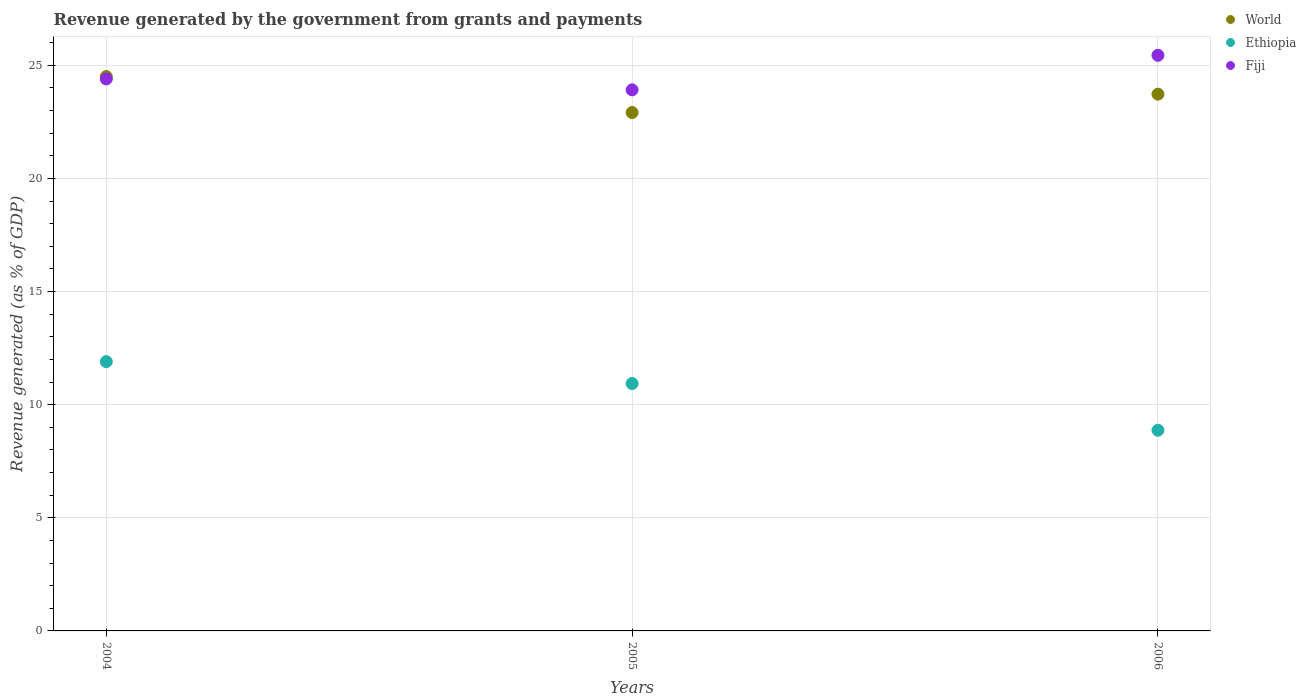How many different coloured dotlines are there?
Provide a succinct answer. 3. Is the number of dotlines equal to the number of legend labels?
Keep it short and to the point. Yes. What is the revenue generated by the government in Ethiopia in 2005?
Provide a short and direct response. 10.94. Across all years, what is the maximum revenue generated by the government in World?
Keep it short and to the point. 24.5. Across all years, what is the minimum revenue generated by the government in Fiji?
Your response must be concise. 23.92. In which year was the revenue generated by the government in World maximum?
Your response must be concise. 2004. What is the total revenue generated by the government in Ethiopia in the graph?
Offer a very short reply. 31.71. What is the difference between the revenue generated by the government in Ethiopia in 2005 and that in 2006?
Offer a very short reply. 2.07. What is the difference between the revenue generated by the government in Fiji in 2006 and the revenue generated by the government in World in 2004?
Keep it short and to the point. 0.94. What is the average revenue generated by the government in World per year?
Give a very brief answer. 23.72. In the year 2004, what is the difference between the revenue generated by the government in Ethiopia and revenue generated by the government in Fiji?
Make the answer very short. -12.5. What is the ratio of the revenue generated by the government in Fiji in 2004 to that in 2006?
Make the answer very short. 0.96. Is the revenue generated by the government in World in 2005 less than that in 2006?
Your answer should be very brief. Yes. What is the difference between the highest and the second highest revenue generated by the government in Ethiopia?
Give a very brief answer. 0.97. What is the difference between the highest and the lowest revenue generated by the government in World?
Your answer should be very brief. 1.59. In how many years, is the revenue generated by the government in World greater than the average revenue generated by the government in World taken over all years?
Keep it short and to the point. 2. Is the sum of the revenue generated by the government in Ethiopia in 2005 and 2006 greater than the maximum revenue generated by the government in World across all years?
Provide a short and direct response. No. Does the revenue generated by the government in Fiji monotonically increase over the years?
Your answer should be very brief. No. Is the revenue generated by the government in Fiji strictly less than the revenue generated by the government in World over the years?
Provide a short and direct response. No. How many years are there in the graph?
Ensure brevity in your answer.  3. What is the difference between two consecutive major ticks on the Y-axis?
Your answer should be compact. 5. Does the graph contain any zero values?
Provide a succinct answer. No. Does the graph contain grids?
Offer a terse response. Yes. How many legend labels are there?
Provide a succinct answer. 3. How are the legend labels stacked?
Give a very brief answer. Vertical. What is the title of the graph?
Your answer should be very brief. Revenue generated by the government from grants and payments. What is the label or title of the X-axis?
Keep it short and to the point. Years. What is the label or title of the Y-axis?
Your answer should be very brief. Revenue generated (as % of GDP). What is the Revenue generated (as % of GDP) in World in 2004?
Your response must be concise. 24.5. What is the Revenue generated (as % of GDP) of Ethiopia in 2004?
Make the answer very short. 11.9. What is the Revenue generated (as % of GDP) of Fiji in 2004?
Ensure brevity in your answer.  24.4. What is the Revenue generated (as % of GDP) of World in 2005?
Offer a terse response. 22.92. What is the Revenue generated (as % of GDP) in Ethiopia in 2005?
Your response must be concise. 10.94. What is the Revenue generated (as % of GDP) of Fiji in 2005?
Ensure brevity in your answer.  23.92. What is the Revenue generated (as % of GDP) in World in 2006?
Keep it short and to the point. 23.73. What is the Revenue generated (as % of GDP) of Ethiopia in 2006?
Offer a very short reply. 8.87. What is the Revenue generated (as % of GDP) in Fiji in 2006?
Give a very brief answer. 25.44. Across all years, what is the maximum Revenue generated (as % of GDP) in World?
Your response must be concise. 24.5. Across all years, what is the maximum Revenue generated (as % of GDP) of Ethiopia?
Your response must be concise. 11.9. Across all years, what is the maximum Revenue generated (as % of GDP) of Fiji?
Your response must be concise. 25.44. Across all years, what is the minimum Revenue generated (as % of GDP) in World?
Your answer should be very brief. 22.92. Across all years, what is the minimum Revenue generated (as % of GDP) in Ethiopia?
Give a very brief answer. 8.87. Across all years, what is the minimum Revenue generated (as % of GDP) in Fiji?
Give a very brief answer. 23.92. What is the total Revenue generated (as % of GDP) of World in the graph?
Your answer should be very brief. 71.15. What is the total Revenue generated (as % of GDP) in Ethiopia in the graph?
Ensure brevity in your answer.  31.71. What is the total Revenue generated (as % of GDP) in Fiji in the graph?
Provide a succinct answer. 73.76. What is the difference between the Revenue generated (as % of GDP) in World in 2004 and that in 2005?
Offer a terse response. 1.59. What is the difference between the Revenue generated (as % of GDP) in Ethiopia in 2004 and that in 2005?
Your response must be concise. 0.97. What is the difference between the Revenue generated (as % of GDP) in Fiji in 2004 and that in 2005?
Give a very brief answer. 0.48. What is the difference between the Revenue generated (as % of GDP) of World in 2004 and that in 2006?
Make the answer very short. 0.78. What is the difference between the Revenue generated (as % of GDP) in Ethiopia in 2004 and that in 2006?
Your answer should be compact. 3.03. What is the difference between the Revenue generated (as % of GDP) of Fiji in 2004 and that in 2006?
Offer a very short reply. -1.04. What is the difference between the Revenue generated (as % of GDP) of World in 2005 and that in 2006?
Keep it short and to the point. -0.81. What is the difference between the Revenue generated (as % of GDP) in Ethiopia in 2005 and that in 2006?
Your answer should be very brief. 2.06. What is the difference between the Revenue generated (as % of GDP) of Fiji in 2005 and that in 2006?
Your answer should be compact. -1.53. What is the difference between the Revenue generated (as % of GDP) in World in 2004 and the Revenue generated (as % of GDP) in Ethiopia in 2005?
Ensure brevity in your answer.  13.57. What is the difference between the Revenue generated (as % of GDP) of World in 2004 and the Revenue generated (as % of GDP) of Fiji in 2005?
Your answer should be compact. 0.59. What is the difference between the Revenue generated (as % of GDP) in Ethiopia in 2004 and the Revenue generated (as % of GDP) in Fiji in 2005?
Offer a terse response. -12.01. What is the difference between the Revenue generated (as % of GDP) in World in 2004 and the Revenue generated (as % of GDP) in Ethiopia in 2006?
Ensure brevity in your answer.  15.63. What is the difference between the Revenue generated (as % of GDP) in World in 2004 and the Revenue generated (as % of GDP) in Fiji in 2006?
Provide a short and direct response. -0.94. What is the difference between the Revenue generated (as % of GDP) in Ethiopia in 2004 and the Revenue generated (as % of GDP) in Fiji in 2006?
Provide a short and direct response. -13.54. What is the difference between the Revenue generated (as % of GDP) in World in 2005 and the Revenue generated (as % of GDP) in Ethiopia in 2006?
Your response must be concise. 14.04. What is the difference between the Revenue generated (as % of GDP) of World in 2005 and the Revenue generated (as % of GDP) of Fiji in 2006?
Your answer should be very brief. -2.53. What is the difference between the Revenue generated (as % of GDP) in Ethiopia in 2005 and the Revenue generated (as % of GDP) in Fiji in 2006?
Ensure brevity in your answer.  -14.51. What is the average Revenue generated (as % of GDP) in World per year?
Provide a succinct answer. 23.72. What is the average Revenue generated (as % of GDP) of Ethiopia per year?
Ensure brevity in your answer.  10.57. What is the average Revenue generated (as % of GDP) of Fiji per year?
Your response must be concise. 24.59. In the year 2004, what is the difference between the Revenue generated (as % of GDP) of World and Revenue generated (as % of GDP) of Ethiopia?
Keep it short and to the point. 12.6. In the year 2004, what is the difference between the Revenue generated (as % of GDP) in World and Revenue generated (as % of GDP) in Fiji?
Provide a short and direct response. 0.1. In the year 2004, what is the difference between the Revenue generated (as % of GDP) in Ethiopia and Revenue generated (as % of GDP) in Fiji?
Offer a terse response. -12.5. In the year 2005, what is the difference between the Revenue generated (as % of GDP) in World and Revenue generated (as % of GDP) in Ethiopia?
Your answer should be very brief. 11.98. In the year 2005, what is the difference between the Revenue generated (as % of GDP) in World and Revenue generated (as % of GDP) in Fiji?
Ensure brevity in your answer.  -1. In the year 2005, what is the difference between the Revenue generated (as % of GDP) of Ethiopia and Revenue generated (as % of GDP) of Fiji?
Offer a very short reply. -12.98. In the year 2006, what is the difference between the Revenue generated (as % of GDP) of World and Revenue generated (as % of GDP) of Ethiopia?
Offer a very short reply. 14.86. In the year 2006, what is the difference between the Revenue generated (as % of GDP) in World and Revenue generated (as % of GDP) in Fiji?
Keep it short and to the point. -1.72. In the year 2006, what is the difference between the Revenue generated (as % of GDP) in Ethiopia and Revenue generated (as % of GDP) in Fiji?
Provide a succinct answer. -16.57. What is the ratio of the Revenue generated (as % of GDP) of World in 2004 to that in 2005?
Provide a succinct answer. 1.07. What is the ratio of the Revenue generated (as % of GDP) in Ethiopia in 2004 to that in 2005?
Give a very brief answer. 1.09. What is the ratio of the Revenue generated (as % of GDP) in Fiji in 2004 to that in 2005?
Offer a terse response. 1.02. What is the ratio of the Revenue generated (as % of GDP) of World in 2004 to that in 2006?
Your response must be concise. 1.03. What is the ratio of the Revenue generated (as % of GDP) in Ethiopia in 2004 to that in 2006?
Your response must be concise. 1.34. What is the ratio of the Revenue generated (as % of GDP) of Fiji in 2004 to that in 2006?
Offer a terse response. 0.96. What is the ratio of the Revenue generated (as % of GDP) of World in 2005 to that in 2006?
Offer a very short reply. 0.97. What is the ratio of the Revenue generated (as % of GDP) of Ethiopia in 2005 to that in 2006?
Your answer should be compact. 1.23. What is the difference between the highest and the second highest Revenue generated (as % of GDP) of World?
Your answer should be very brief. 0.78. What is the difference between the highest and the second highest Revenue generated (as % of GDP) in Ethiopia?
Your answer should be compact. 0.97. What is the difference between the highest and the second highest Revenue generated (as % of GDP) in Fiji?
Offer a very short reply. 1.04. What is the difference between the highest and the lowest Revenue generated (as % of GDP) of World?
Give a very brief answer. 1.59. What is the difference between the highest and the lowest Revenue generated (as % of GDP) of Ethiopia?
Offer a very short reply. 3.03. What is the difference between the highest and the lowest Revenue generated (as % of GDP) of Fiji?
Make the answer very short. 1.53. 